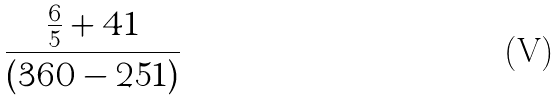<formula> <loc_0><loc_0><loc_500><loc_500>\frac { \frac { 6 } { 5 } + 4 1 } { ( 3 6 0 - 2 5 1 ) }</formula> 